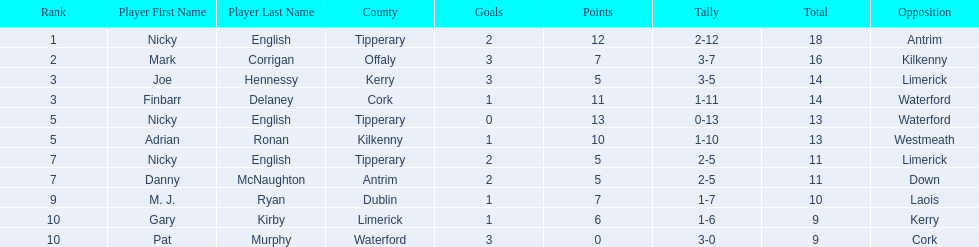Who are all the players? Nicky English, Mark Corrigan, Joe Hennessy, Finbarr Delaney, Nicky English, Adrian Ronan, Nicky English, Danny McNaughton, M. J. Ryan, Gary Kirby, Pat Murphy. How many points did they receive? 18, 16, 14, 14, 13, 13, 11, 11, 10, 9, 9. And which player received 10 points? M. J. Ryan. 